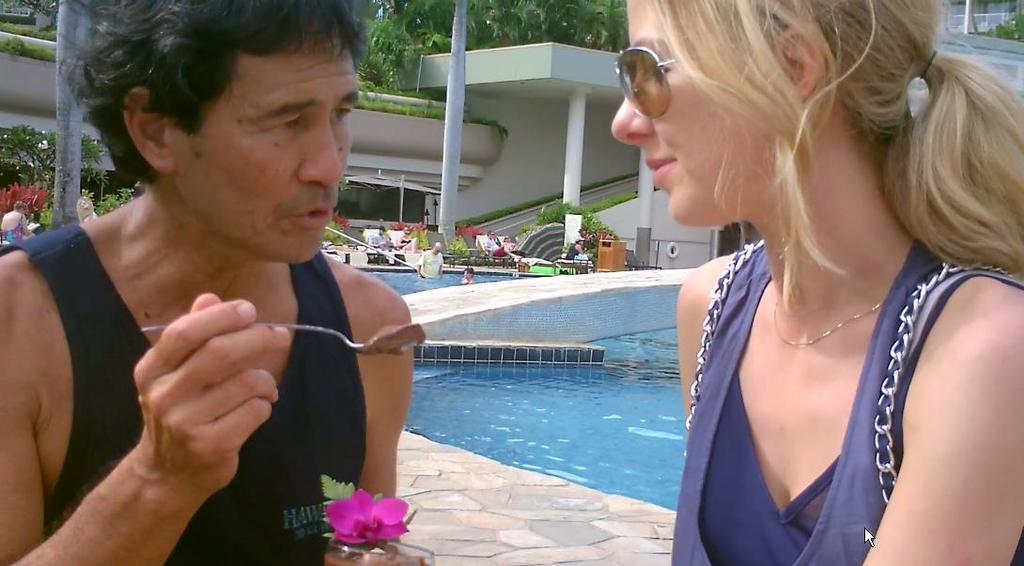Please provide a concise description of this image. In this image, on the right side, we can see a woman wearing a blue color dress. On the left side, we can also see a man holding a spoon in his hand. On the left side, we can also see a glass with some drink. In the background, we can see two people are in the swimming pool, group of people, trees, building, pillars, at the bottom, we can see water in a pool. 